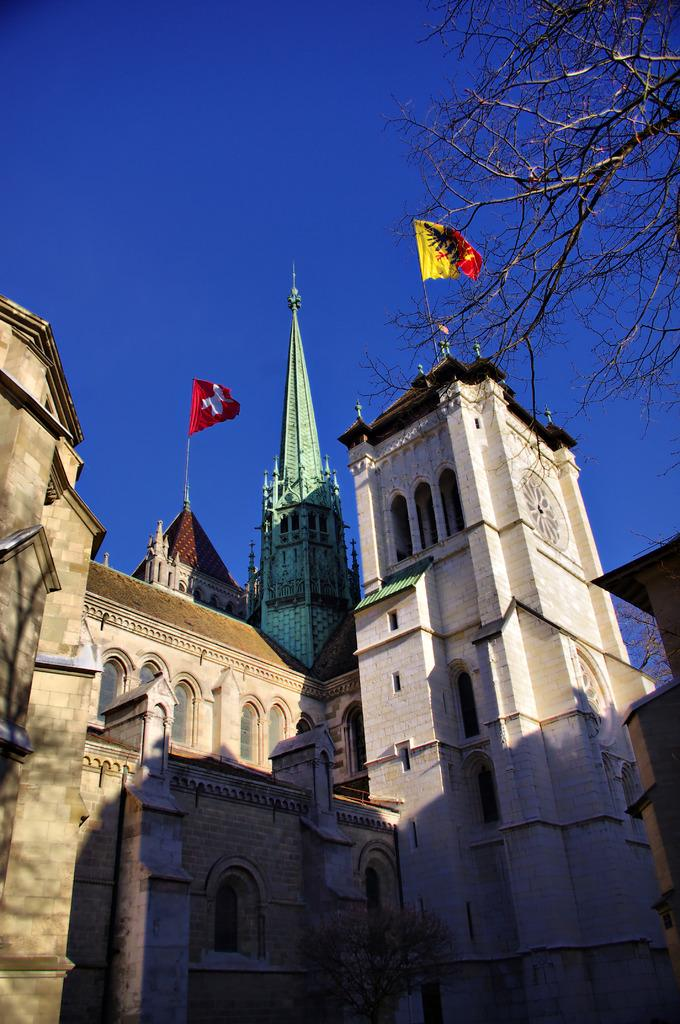What type of structures can be seen in the image? There are buildings in the image. What additional elements are present in the image? There are flags and trees in the image. What part of the natural environment is visible in the image? The sky is visible in the image. How many oranges are hanging from the trees in the image? There are no oranges present in the image; it features buildings, flags, trees, and the sky. 